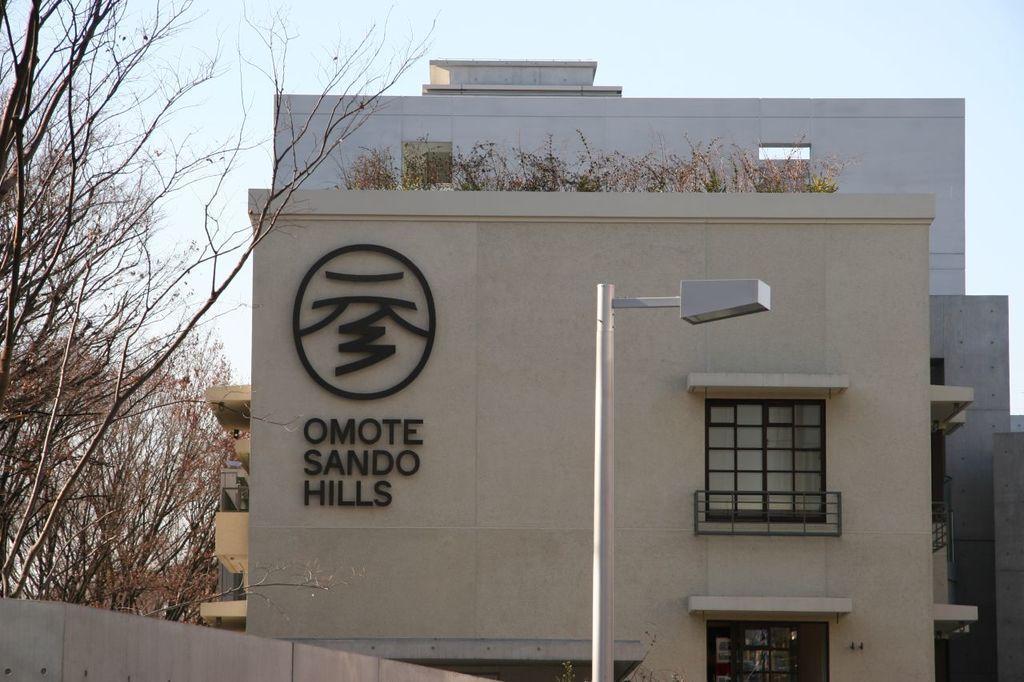In one or two sentences, can you explain what this image depicts? In this image I can see a street light pole, few trees and a building which is cream in color. In the background I can see few other buildings and the sky. 